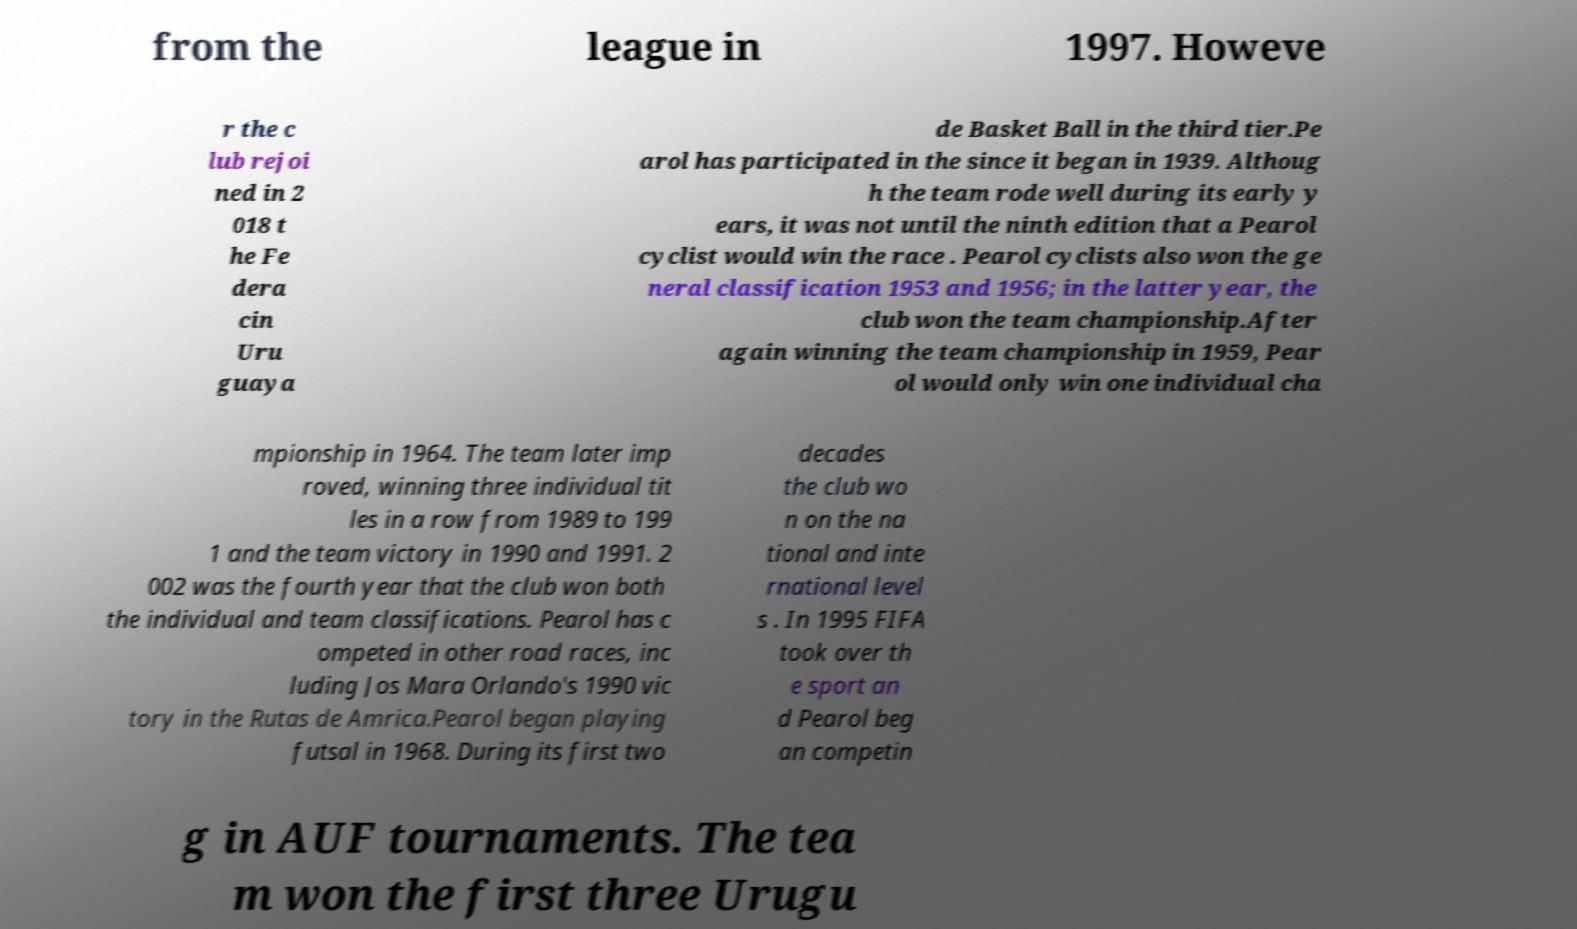Can you read and provide the text displayed in the image?This photo seems to have some interesting text. Can you extract and type it out for me? from the league in 1997. Howeve r the c lub rejoi ned in 2 018 t he Fe dera cin Uru guaya de Basket Ball in the third tier.Pe arol has participated in the since it began in 1939. Althoug h the team rode well during its early y ears, it was not until the ninth edition that a Pearol cyclist would win the race . Pearol cyclists also won the ge neral classification 1953 and 1956; in the latter year, the club won the team championship.After again winning the team championship in 1959, Pear ol would only win one individual cha mpionship in 1964. The team later imp roved, winning three individual tit les in a row from 1989 to 199 1 and the team victory in 1990 and 1991. 2 002 was the fourth year that the club won both the individual and team classifications. Pearol has c ompeted in other road races, inc luding Jos Mara Orlando's 1990 vic tory in the Rutas de Amrica.Pearol began playing futsal in 1968. During its first two decades the club wo n on the na tional and inte rnational level s . In 1995 FIFA took over th e sport an d Pearol beg an competin g in AUF tournaments. The tea m won the first three Urugu 